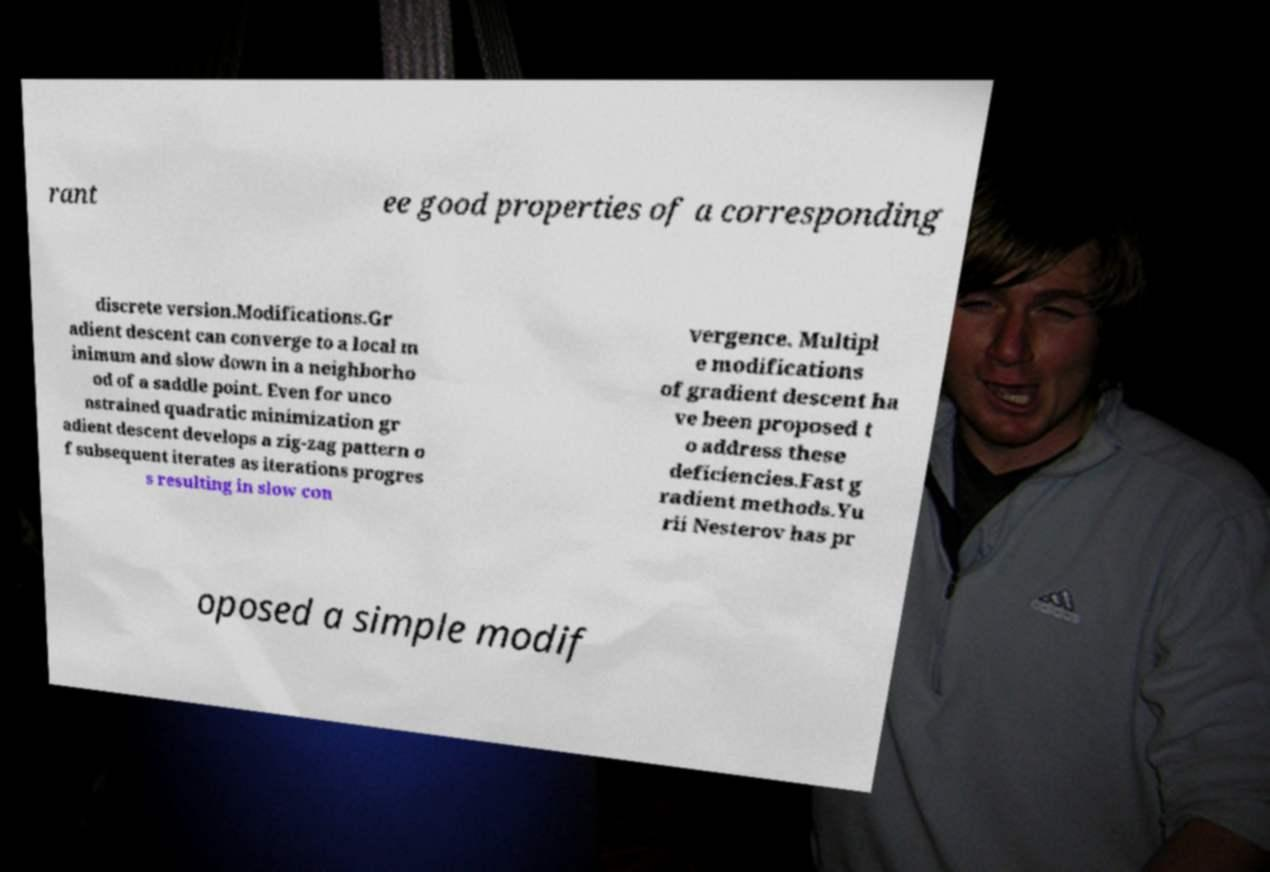Could you extract and type out the text from this image? rant ee good properties of a corresponding discrete version.Modifications.Gr adient descent can converge to a local m inimum and slow down in a neighborho od of a saddle point. Even for unco nstrained quadratic minimization gr adient descent develops a zig-zag pattern o f subsequent iterates as iterations progres s resulting in slow con vergence. Multipl e modifications of gradient descent ha ve been proposed t o address these deficiencies.Fast g radient methods.Yu rii Nesterov has pr oposed a simple modif 